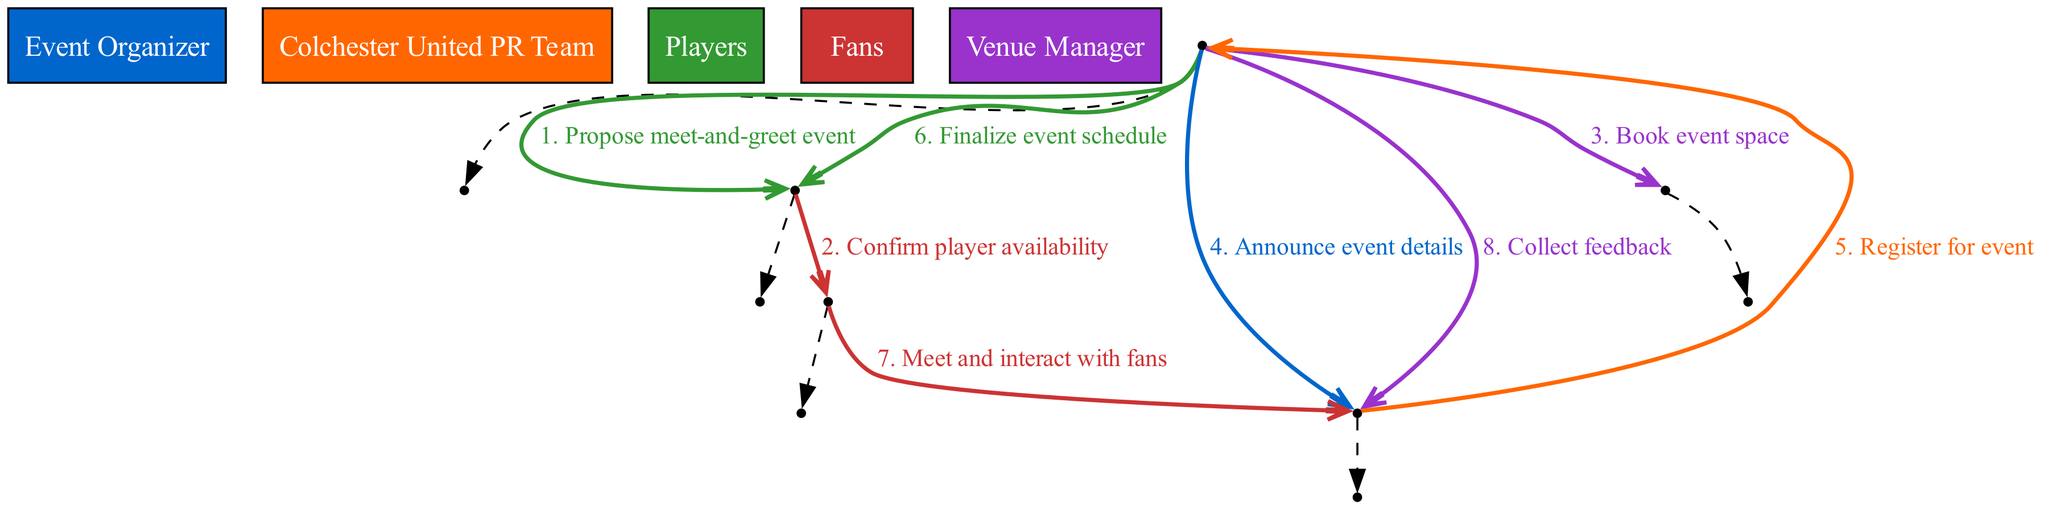What is the first action proposed in the diagram? The first action is "Propose meet-and-greet event," which is initiated by the Event Organizer. This is the first message in the sequence diagram from the Event Organizer to the Colchester United PR Team.
Answer: Propose meet-and-greet event How many participants are involved in the sequence? There are five participants listed in the diagram: Event Organizer, Colchester United PR Team, Players, Fans, and Venue Manager. Counting these participants gives us a total of five.
Answer: Five Which participant communicates the event details to the fans? The Event Organizer is responsible for announcing the event details to the Fans. This action is explicitly mentioned in the sequence when the Event Organizer sends a message to the Fans.
Answer: Event Organizer What is the last action taken in the sequence? The last action taken is "Collect feedback," where the Event Organizer requests feedback from the Fans. This is the final step listed in the sequence.
Answer: Collect feedback How many messages are sent from the players to the fans? There is one message in the sequence where the Players meet and interact with the Fans. Thus, there is a single direct communication from the Players to the Fans as shown in the diagram.
Answer: One Which participant needs to confirm player availability? The Colchester United PR Team is the participant responsible for confirming player availability. This is shown in the second step of the sequence where the PR Team communicates with the Players.
Answer: Colchester United PR Team What message number corresponds to the interaction between players and fans? The interaction between Players and Fans occurs as the seventh message in the sequence, as indicated by the numbering in the diagram.
Answer: Seven Which participant books the event space? The Event Organizer is the participant who books the event space. This action is shown in the communication from the Event Organizer to the Venue Manager in the sequence.
Answer: Event Organizer 